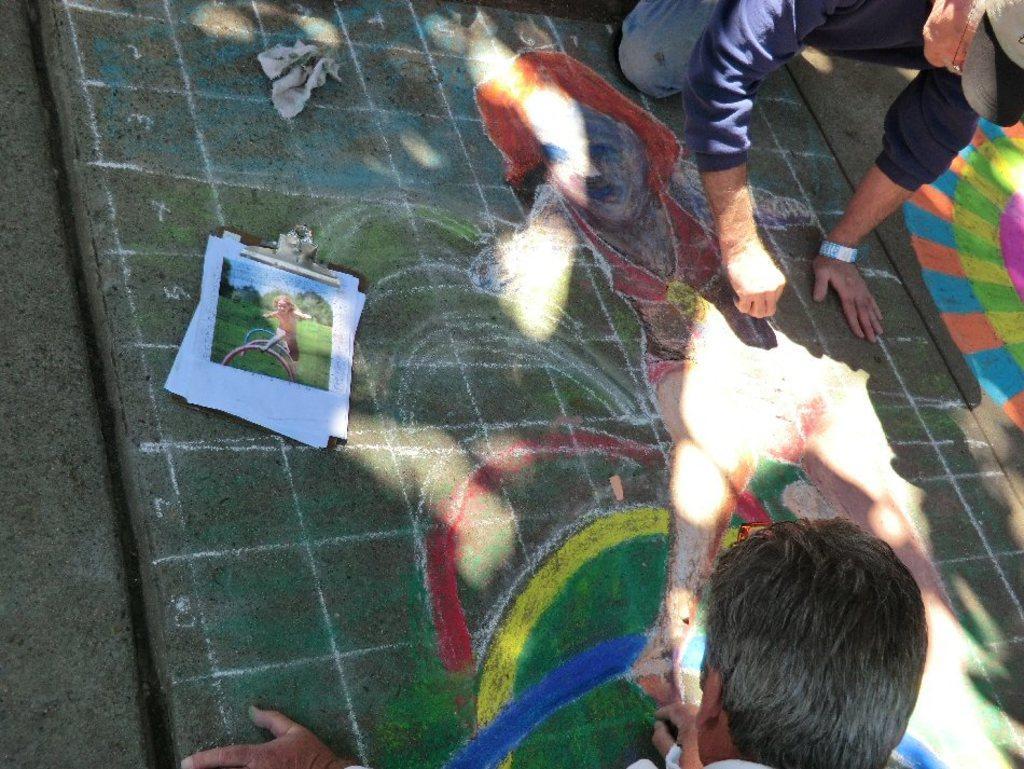Describe this image in one or two sentences. In this picture, we can see a few people and some art on the ground and we can see some objects on the ground. 